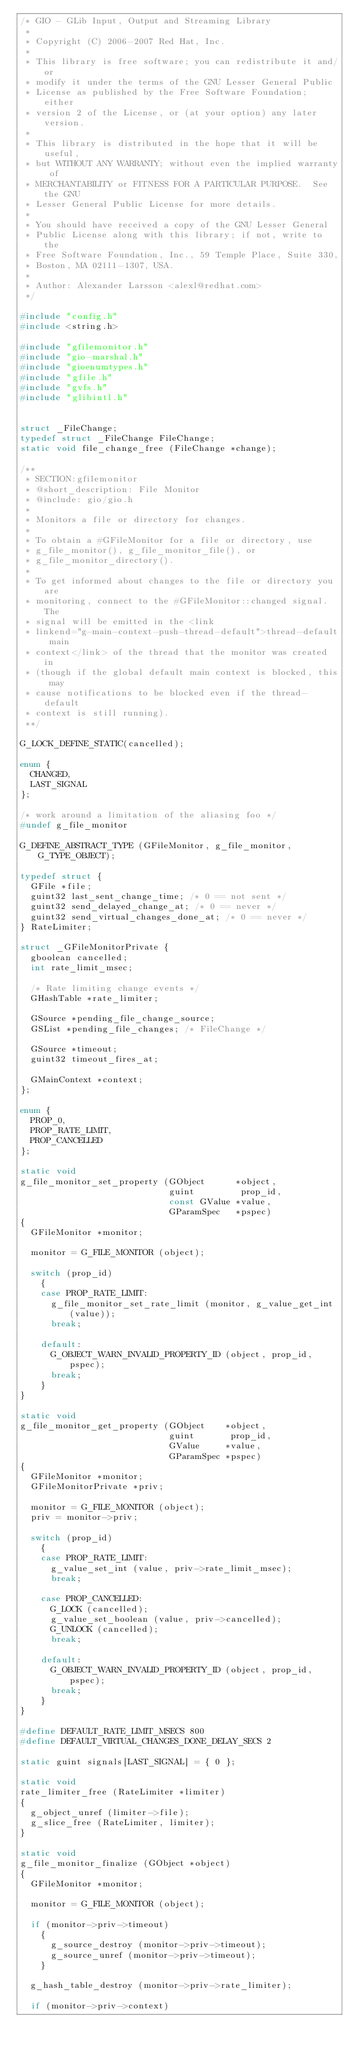<code> <loc_0><loc_0><loc_500><loc_500><_C_>/* GIO - GLib Input, Output and Streaming Library
 * 
 * Copyright (C) 2006-2007 Red Hat, Inc.
 *
 * This library is free software; you can redistribute it and/or
 * modify it under the terms of the GNU Lesser General Public
 * License as published by the Free Software Foundation; either
 * version 2 of the License, or (at your option) any later version.
 *
 * This library is distributed in the hope that it will be useful,
 * but WITHOUT ANY WARRANTY; without even the implied warranty of
 * MERCHANTABILITY or FITNESS FOR A PARTICULAR PURPOSE.  See the GNU
 * Lesser General Public License for more details.
 *
 * You should have received a copy of the GNU Lesser General
 * Public License along with this library; if not, write to the
 * Free Software Foundation, Inc., 59 Temple Place, Suite 330,
 * Boston, MA 02111-1307, USA.
 *
 * Author: Alexander Larsson <alexl@redhat.com>
 */

#include "config.h"
#include <string.h>

#include "gfilemonitor.h"
#include "gio-marshal.h"
#include "gioenumtypes.h"
#include "gfile.h"
#include "gvfs.h"
#include "glibintl.h"


struct _FileChange;
typedef struct _FileChange FileChange;
static void file_change_free (FileChange *change);

/**
 * SECTION:gfilemonitor
 * @short_description: File Monitor
 * @include: gio/gio.h
 *
 * Monitors a file or directory for changes.
 *
 * To obtain a #GFileMonitor for a file or directory, use
 * g_file_monitor(), g_file_monitor_file(), or
 * g_file_monitor_directory().
 *
 * To get informed about changes to the file or directory you are
 * monitoring, connect to the #GFileMonitor::changed signal. The
 * signal will be emitted in the <link
 * linkend="g-main-context-push-thread-default">thread-default main
 * context</link> of the thread that the monitor was created in
 * (though if the global default main context is blocked, this may
 * cause notifications to be blocked even if the thread-default
 * context is still running).
 **/

G_LOCK_DEFINE_STATIC(cancelled);

enum {
  CHANGED,
  LAST_SIGNAL
};

/* work around a limitation of the aliasing foo */
#undef g_file_monitor

G_DEFINE_ABSTRACT_TYPE (GFileMonitor, g_file_monitor, G_TYPE_OBJECT);

typedef struct {
  GFile *file;
  guint32 last_sent_change_time; /* 0 == not sent */
  guint32 send_delayed_change_at; /* 0 == never */
  guint32 send_virtual_changes_done_at; /* 0 == never */
} RateLimiter;

struct _GFileMonitorPrivate {
  gboolean cancelled;
  int rate_limit_msec;

  /* Rate limiting change events */
  GHashTable *rate_limiter;

  GSource *pending_file_change_source;
  GSList *pending_file_changes; /* FileChange */

  GSource *timeout;
  guint32 timeout_fires_at;

  GMainContext *context;
};

enum {
  PROP_0,
  PROP_RATE_LIMIT,
  PROP_CANCELLED
};

static void
g_file_monitor_set_property (GObject      *object,
                             guint         prop_id,
                             const GValue *value,
                             GParamSpec   *pspec)
{
  GFileMonitor *monitor;

  monitor = G_FILE_MONITOR (object);

  switch (prop_id)
    {
    case PROP_RATE_LIMIT:
      g_file_monitor_set_rate_limit (monitor, g_value_get_int (value));
      break;

    default:
      G_OBJECT_WARN_INVALID_PROPERTY_ID (object, prop_id, pspec);
      break;
    }
}

static void
g_file_monitor_get_property (GObject    *object,
                             guint       prop_id,
                             GValue     *value,
                             GParamSpec *pspec)
{
  GFileMonitor *monitor;
  GFileMonitorPrivate *priv;

  monitor = G_FILE_MONITOR (object);
  priv = monitor->priv;

  switch (prop_id)
    {
    case PROP_RATE_LIMIT:
      g_value_set_int (value, priv->rate_limit_msec);
      break;

    case PROP_CANCELLED:
      G_LOCK (cancelled);
      g_value_set_boolean (value, priv->cancelled);
      G_UNLOCK (cancelled);
      break;

    default:
      G_OBJECT_WARN_INVALID_PROPERTY_ID (object, prop_id, pspec);
      break;
    }
}

#define DEFAULT_RATE_LIMIT_MSECS 800
#define DEFAULT_VIRTUAL_CHANGES_DONE_DELAY_SECS 2

static guint signals[LAST_SIGNAL] = { 0 };

static void
rate_limiter_free (RateLimiter *limiter)
{
  g_object_unref (limiter->file);
  g_slice_free (RateLimiter, limiter);
}

static void
g_file_monitor_finalize (GObject *object)
{
  GFileMonitor *monitor;

  monitor = G_FILE_MONITOR (object);

  if (monitor->priv->timeout)
    {
      g_source_destroy (monitor->priv->timeout);
      g_source_unref (monitor->priv->timeout);
    }

  g_hash_table_destroy (monitor->priv->rate_limiter);

  if (monitor->priv->context)</code> 